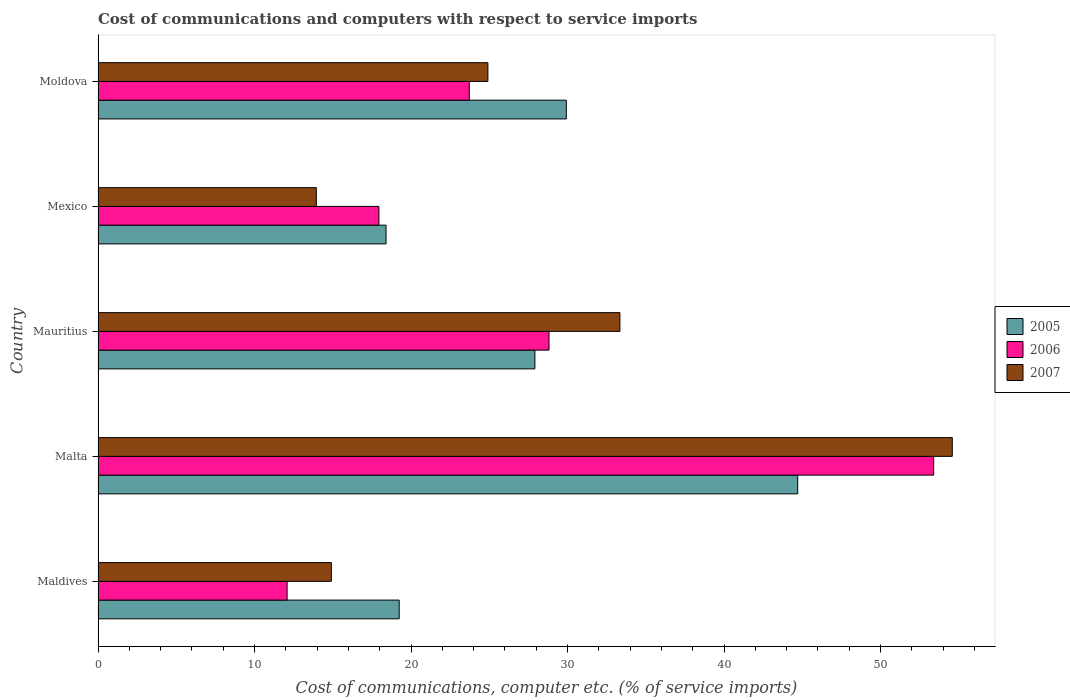How many different coloured bars are there?
Offer a very short reply. 3. Are the number of bars on each tick of the Y-axis equal?
Keep it short and to the point. Yes. What is the label of the 2nd group of bars from the top?
Keep it short and to the point. Mexico. What is the cost of communications and computers in 2007 in Mauritius?
Provide a succinct answer. 33.35. Across all countries, what is the maximum cost of communications and computers in 2005?
Your response must be concise. 44.71. Across all countries, what is the minimum cost of communications and computers in 2005?
Keep it short and to the point. 18.4. In which country was the cost of communications and computers in 2007 maximum?
Make the answer very short. Malta. What is the total cost of communications and computers in 2005 in the graph?
Your response must be concise. 140.18. What is the difference between the cost of communications and computers in 2005 in Maldives and that in Mauritius?
Offer a terse response. -8.67. What is the difference between the cost of communications and computers in 2006 in Maldives and the cost of communications and computers in 2005 in Mexico?
Give a very brief answer. -6.32. What is the average cost of communications and computers in 2005 per country?
Offer a terse response. 28.04. What is the difference between the cost of communications and computers in 2006 and cost of communications and computers in 2005 in Malta?
Your answer should be very brief. 8.69. In how many countries, is the cost of communications and computers in 2007 greater than 14 %?
Keep it short and to the point. 4. What is the ratio of the cost of communications and computers in 2005 in Maldives to that in Malta?
Offer a terse response. 0.43. Is the cost of communications and computers in 2006 in Mauritius less than that in Moldova?
Keep it short and to the point. No. What is the difference between the highest and the second highest cost of communications and computers in 2006?
Offer a terse response. 24.58. What is the difference between the highest and the lowest cost of communications and computers in 2005?
Make the answer very short. 26.3. In how many countries, is the cost of communications and computers in 2005 greater than the average cost of communications and computers in 2005 taken over all countries?
Provide a short and direct response. 2. What does the 2nd bar from the bottom in Mexico represents?
Provide a succinct answer. 2006. Is it the case that in every country, the sum of the cost of communications and computers in 2006 and cost of communications and computers in 2005 is greater than the cost of communications and computers in 2007?
Ensure brevity in your answer.  Yes. How many bars are there?
Keep it short and to the point. 15. What is the difference between two consecutive major ticks on the X-axis?
Keep it short and to the point. 10. Are the values on the major ticks of X-axis written in scientific E-notation?
Ensure brevity in your answer.  No. Does the graph contain any zero values?
Ensure brevity in your answer.  No. Where does the legend appear in the graph?
Offer a very short reply. Center right. How many legend labels are there?
Offer a very short reply. 3. How are the legend labels stacked?
Keep it short and to the point. Vertical. What is the title of the graph?
Make the answer very short. Cost of communications and computers with respect to service imports. What is the label or title of the X-axis?
Ensure brevity in your answer.  Cost of communications, computer etc. (% of service imports). What is the Cost of communications, computer etc. (% of service imports) in 2005 in Maldives?
Provide a succinct answer. 19.24. What is the Cost of communications, computer etc. (% of service imports) of 2006 in Maldives?
Offer a terse response. 12.08. What is the Cost of communications, computer etc. (% of service imports) in 2007 in Maldives?
Keep it short and to the point. 14.91. What is the Cost of communications, computer etc. (% of service imports) of 2005 in Malta?
Your answer should be compact. 44.71. What is the Cost of communications, computer etc. (% of service imports) in 2006 in Malta?
Provide a short and direct response. 53.4. What is the Cost of communications, computer etc. (% of service imports) of 2007 in Malta?
Offer a very short reply. 54.58. What is the Cost of communications, computer etc. (% of service imports) of 2005 in Mauritius?
Offer a terse response. 27.91. What is the Cost of communications, computer etc. (% of service imports) in 2006 in Mauritius?
Give a very brief answer. 28.82. What is the Cost of communications, computer etc. (% of service imports) in 2007 in Mauritius?
Ensure brevity in your answer.  33.35. What is the Cost of communications, computer etc. (% of service imports) of 2005 in Mexico?
Offer a terse response. 18.4. What is the Cost of communications, computer etc. (% of service imports) in 2006 in Mexico?
Keep it short and to the point. 17.95. What is the Cost of communications, computer etc. (% of service imports) of 2007 in Mexico?
Keep it short and to the point. 13.95. What is the Cost of communications, computer etc. (% of service imports) of 2005 in Moldova?
Keep it short and to the point. 29.92. What is the Cost of communications, computer etc. (% of service imports) of 2006 in Moldova?
Offer a terse response. 23.72. What is the Cost of communications, computer etc. (% of service imports) in 2007 in Moldova?
Offer a terse response. 24.91. Across all countries, what is the maximum Cost of communications, computer etc. (% of service imports) in 2005?
Your answer should be very brief. 44.71. Across all countries, what is the maximum Cost of communications, computer etc. (% of service imports) of 2006?
Make the answer very short. 53.4. Across all countries, what is the maximum Cost of communications, computer etc. (% of service imports) in 2007?
Keep it short and to the point. 54.58. Across all countries, what is the minimum Cost of communications, computer etc. (% of service imports) in 2005?
Provide a short and direct response. 18.4. Across all countries, what is the minimum Cost of communications, computer etc. (% of service imports) of 2006?
Your answer should be very brief. 12.08. Across all countries, what is the minimum Cost of communications, computer etc. (% of service imports) of 2007?
Make the answer very short. 13.95. What is the total Cost of communications, computer etc. (% of service imports) in 2005 in the graph?
Provide a succinct answer. 140.18. What is the total Cost of communications, computer etc. (% of service imports) in 2006 in the graph?
Your response must be concise. 135.96. What is the total Cost of communications, computer etc. (% of service imports) of 2007 in the graph?
Offer a terse response. 141.69. What is the difference between the Cost of communications, computer etc. (% of service imports) in 2005 in Maldives and that in Malta?
Ensure brevity in your answer.  -25.46. What is the difference between the Cost of communications, computer etc. (% of service imports) of 2006 in Maldives and that in Malta?
Keep it short and to the point. -41.31. What is the difference between the Cost of communications, computer etc. (% of service imports) of 2007 in Maldives and that in Malta?
Keep it short and to the point. -39.68. What is the difference between the Cost of communications, computer etc. (% of service imports) in 2005 in Maldives and that in Mauritius?
Keep it short and to the point. -8.67. What is the difference between the Cost of communications, computer etc. (% of service imports) in 2006 in Maldives and that in Mauritius?
Offer a terse response. -16.73. What is the difference between the Cost of communications, computer etc. (% of service imports) in 2007 in Maldives and that in Mauritius?
Your answer should be very brief. -18.44. What is the difference between the Cost of communications, computer etc. (% of service imports) of 2005 in Maldives and that in Mexico?
Make the answer very short. 0.84. What is the difference between the Cost of communications, computer etc. (% of service imports) of 2006 in Maldives and that in Mexico?
Keep it short and to the point. -5.87. What is the difference between the Cost of communications, computer etc. (% of service imports) of 2007 in Maldives and that in Mexico?
Offer a very short reply. 0.96. What is the difference between the Cost of communications, computer etc. (% of service imports) of 2005 in Maldives and that in Moldova?
Make the answer very short. -10.68. What is the difference between the Cost of communications, computer etc. (% of service imports) of 2006 in Maldives and that in Moldova?
Make the answer very short. -11.64. What is the difference between the Cost of communications, computer etc. (% of service imports) of 2007 in Maldives and that in Moldova?
Your answer should be very brief. -10. What is the difference between the Cost of communications, computer etc. (% of service imports) in 2005 in Malta and that in Mauritius?
Offer a terse response. 16.79. What is the difference between the Cost of communications, computer etc. (% of service imports) in 2006 in Malta and that in Mauritius?
Keep it short and to the point. 24.58. What is the difference between the Cost of communications, computer etc. (% of service imports) of 2007 in Malta and that in Mauritius?
Provide a short and direct response. 21.24. What is the difference between the Cost of communications, computer etc. (% of service imports) in 2005 in Malta and that in Mexico?
Make the answer very short. 26.3. What is the difference between the Cost of communications, computer etc. (% of service imports) of 2006 in Malta and that in Mexico?
Provide a succinct answer. 35.45. What is the difference between the Cost of communications, computer etc. (% of service imports) of 2007 in Malta and that in Mexico?
Your answer should be compact. 40.64. What is the difference between the Cost of communications, computer etc. (% of service imports) of 2005 in Malta and that in Moldova?
Keep it short and to the point. 14.79. What is the difference between the Cost of communications, computer etc. (% of service imports) of 2006 in Malta and that in Moldova?
Your answer should be compact. 29.67. What is the difference between the Cost of communications, computer etc. (% of service imports) in 2007 in Malta and that in Moldova?
Your response must be concise. 29.67. What is the difference between the Cost of communications, computer etc. (% of service imports) in 2005 in Mauritius and that in Mexico?
Your answer should be compact. 9.51. What is the difference between the Cost of communications, computer etc. (% of service imports) in 2006 in Mauritius and that in Mexico?
Offer a terse response. 10.87. What is the difference between the Cost of communications, computer etc. (% of service imports) in 2007 in Mauritius and that in Mexico?
Your answer should be very brief. 19.4. What is the difference between the Cost of communications, computer etc. (% of service imports) of 2005 in Mauritius and that in Moldova?
Your response must be concise. -2.01. What is the difference between the Cost of communications, computer etc. (% of service imports) in 2006 in Mauritius and that in Moldova?
Your response must be concise. 5.09. What is the difference between the Cost of communications, computer etc. (% of service imports) of 2007 in Mauritius and that in Moldova?
Make the answer very short. 8.44. What is the difference between the Cost of communications, computer etc. (% of service imports) of 2005 in Mexico and that in Moldova?
Ensure brevity in your answer.  -11.52. What is the difference between the Cost of communications, computer etc. (% of service imports) of 2006 in Mexico and that in Moldova?
Your answer should be very brief. -5.77. What is the difference between the Cost of communications, computer etc. (% of service imports) of 2007 in Mexico and that in Moldova?
Give a very brief answer. -10.96. What is the difference between the Cost of communications, computer etc. (% of service imports) in 2005 in Maldives and the Cost of communications, computer etc. (% of service imports) in 2006 in Malta?
Your answer should be compact. -34.15. What is the difference between the Cost of communications, computer etc. (% of service imports) in 2005 in Maldives and the Cost of communications, computer etc. (% of service imports) in 2007 in Malta?
Ensure brevity in your answer.  -35.34. What is the difference between the Cost of communications, computer etc. (% of service imports) in 2006 in Maldives and the Cost of communications, computer etc. (% of service imports) in 2007 in Malta?
Provide a succinct answer. -42.5. What is the difference between the Cost of communications, computer etc. (% of service imports) in 2005 in Maldives and the Cost of communications, computer etc. (% of service imports) in 2006 in Mauritius?
Give a very brief answer. -9.57. What is the difference between the Cost of communications, computer etc. (% of service imports) in 2005 in Maldives and the Cost of communications, computer etc. (% of service imports) in 2007 in Mauritius?
Offer a terse response. -14.1. What is the difference between the Cost of communications, computer etc. (% of service imports) in 2006 in Maldives and the Cost of communications, computer etc. (% of service imports) in 2007 in Mauritius?
Provide a succinct answer. -21.27. What is the difference between the Cost of communications, computer etc. (% of service imports) of 2005 in Maldives and the Cost of communications, computer etc. (% of service imports) of 2006 in Mexico?
Your response must be concise. 1.3. What is the difference between the Cost of communications, computer etc. (% of service imports) in 2005 in Maldives and the Cost of communications, computer etc. (% of service imports) in 2007 in Mexico?
Provide a succinct answer. 5.3. What is the difference between the Cost of communications, computer etc. (% of service imports) of 2006 in Maldives and the Cost of communications, computer etc. (% of service imports) of 2007 in Mexico?
Offer a terse response. -1.87. What is the difference between the Cost of communications, computer etc. (% of service imports) of 2005 in Maldives and the Cost of communications, computer etc. (% of service imports) of 2006 in Moldova?
Offer a terse response. -4.48. What is the difference between the Cost of communications, computer etc. (% of service imports) of 2005 in Maldives and the Cost of communications, computer etc. (% of service imports) of 2007 in Moldova?
Offer a very short reply. -5.67. What is the difference between the Cost of communications, computer etc. (% of service imports) in 2006 in Maldives and the Cost of communications, computer etc. (% of service imports) in 2007 in Moldova?
Your answer should be very brief. -12.83. What is the difference between the Cost of communications, computer etc. (% of service imports) in 2005 in Malta and the Cost of communications, computer etc. (% of service imports) in 2006 in Mauritius?
Ensure brevity in your answer.  15.89. What is the difference between the Cost of communications, computer etc. (% of service imports) in 2005 in Malta and the Cost of communications, computer etc. (% of service imports) in 2007 in Mauritius?
Ensure brevity in your answer.  11.36. What is the difference between the Cost of communications, computer etc. (% of service imports) of 2006 in Malta and the Cost of communications, computer etc. (% of service imports) of 2007 in Mauritius?
Your answer should be compact. 20.05. What is the difference between the Cost of communications, computer etc. (% of service imports) in 2005 in Malta and the Cost of communications, computer etc. (% of service imports) in 2006 in Mexico?
Offer a terse response. 26.76. What is the difference between the Cost of communications, computer etc. (% of service imports) of 2005 in Malta and the Cost of communications, computer etc. (% of service imports) of 2007 in Mexico?
Keep it short and to the point. 30.76. What is the difference between the Cost of communications, computer etc. (% of service imports) of 2006 in Malta and the Cost of communications, computer etc. (% of service imports) of 2007 in Mexico?
Make the answer very short. 39.45. What is the difference between the Cost of communications, computer etc. (% of service imports) of 2005 in Malta and the Cost of communications, computer etc. (% of service imports) of 2006 in Moldova?
Offer a terse response. 20.99. What is the difference between the Cost of communications, computer etc. (% of service imports) in 2005 in Malta and the Cost of communications, computer etc. (% of service imports) in 2007 in Moldova?
Offer a very short reply. 19.8. What is the difference between the Cost of communications, computer etc. (% of service imports) in 2006 in Malta and the Cost of communications, computer etc. (% of service imports) in 2007 in Moldova?
Make the answer very short. 28.49. What is the difference between the Cost of communications, computer etc. (% of service imports) of 2005 in Mauritius and the Cost of communications, computer etc. (% of service imports) of 2006 in Mexico?
Your answer should be compact. 9.97. What is the difference between the Cost of communications, computer etc. (% of service imports) in 2005 in Mauritius and the Cost of communications, computer etc. (% of service imports) in 2007 in Mexico?
Provide a short and direct response. 13.97. What is the difference between the Cost of communications, computer etc. (% of service imports) in 2006 in Mauritius and the Cost of communications, computer etc. (% of service imports) in 2007 in Mexico?
Ensure brevity in your answer.  14.87. What is the difference between the Cost of communications, computer etc. (% of service imports) in 2005 in Mauritius and the Cost of communications, computer etc. (% of service imports) in 2006 in Moldova?
Offer a terse response. 4.19. What is the difference between the Cost of communications, computer etc. (% of service imports) of 2005 in Mauritius and the Cost of communications, computer etc. (% of service imports) of 2007 in Moldova?
Offer a terse response. 3. What is the difference between the Cost of communications, computer etc. (% of service imports) in 2006 in Mauritius and the Cost of communications, computer etc. (% of service imports) in 2007 in Moldova?
Provide a succinct answer. 3.91. What is the difference between the Cost of communications, computer etc. (% of service imports) of 2005 in Mexico and the Cost of communications, computer etc. (% of service imports) of 2006 in Moldova?
Ensure brevity in your answer.  -5.32. What is the difference between the Cost of communications, computer etc. (% of service imports) of 2005 in Mexico and the Cost of communications, computer etc. (% of service imports) of 2007 in Moldova?
Keep it short and to the point. -6.51. What is the difference between the Cost of communications, computer etc. (% of service imports) of 2006 in Mexico and the Cost of communications, computer etc. (% of service imports) of 2007 in Moldova?
Your response must be concise. -6.96. What is the average Cost of communications, computer etc. (% of service imports) of 2005 per country?
Keep it short and to the point. 28.04. What is the average Cost of communications, computer etc. (% of service imports) of 2006 per country?
Your answer should be very brief. 27.19. What is the average Cost of communications, computer etc. (% of service imports) in 2007 per country?
Your answer should be very brief. 28.34. What is the difference between the Cost of communications, computer etc. (% of service imports) in 2005 and Cost of communications, computer etc. (% of service imports) in 2006 in Maldives?
Your response must be concise. 7.16. What is the difference between the Cost of communications, computer etc. (% of service imports) in 2005 and Cost of communications, computer etc. (% of service imports) in 2007 in Maldives?
Ensure brevity in your answer.  4.33. What is the difference between the Cost of communications, computer etc. (% of service imports) in 2006 and Cost of communications, computer etc. (% of service imports) in 2007 in Maldives?
Give a very brief answer. -2.83. What is the difference between the Cost of communications, computer etc. (% of service imports) of 2005 and Cost of communications, computer etc. (% of service imports) of 2006 in Malta?
Provide a short and direct response. -8.69. What is the difference between the Cost of communications, computer etc. (% of service imports) of 2005 and Cost of communications, computer etc. (% of service imports) of 2007 in Malta?
Your answer should be very brief. -9.88. What is the difference between the Cost of communications, computer etc. (% of service imports) of 2006 and Cost of communications, computer etc. (% of service imports) of 2007 in Malta?
Provide a short and direct response. -1.19. What is the difference between the Cost of communications, computer etc. (% of service imports) of 2005 and Cost of communications, computer etc. (% of service imports) of 2006 in Mauritius?
Your answer should be very brief. -0.9. What is the difference between the Cost of communications, computer etc. (% of service imports) of 2005 and Cost of communications, computer etc. (% of service imports) of 2007 in Mauritius?
Your response must be concise. -5.43. What is the difference between the Cost of communications, computer etc. (% of service imports) in 2006 and Cost of communications, computer etc. (% of service imports) in 2007 in Mauritius?
Your answer should be very brief. -4.53. What is the difference between the Cost of communications, computer etc. (% of service imports) of 2005 and Cost of communications, computer etc. (% of service imports) of 2006 in Mexico?
Your response must be concise. 0.46. What is the difference between the Cost of communications, computer etc. (% of service imports) in 2005 and Cost of communications, computer etc. (% of service imports) in 2007 in Mexico?
Ensure brevity in your answer.  4.46. What is the difference between the Cost of communications, computer etc. (% of service imports) of 2006 and Cost of communications, computer etc. (% of service imports) of 2007 in Mexico?
Provide a short and direct response. 4. What is the difference between the Cost of communications, computer etc. (% of service imports) in 2005 and Cost of communications, computer etc. (% of service imports) in 2007 in Moldova?
Offer a terse response. 5.01. What is the difference between the Cost of communications, computer etc. (% of service imports) in 2006 and Cost of communications, computer etc. (% of service imports) in 2007 in Moldova?
Offer a terse response. -1.19. What is the ratio of the Cost of communications, computer etc. (% of service imports) of 2005 in Maldives to that in Malta?
Offer a very short reply. 0.43. What is the ratio of the Cost of communications, computer etc. (% of service imports) of 2006 in Maldives to that in Malta?
Offer a terse response. 0.23. What is the ratio of the Cost of communications, computer etc. (% of service imports) of 2007 in Maldives to that in Malta?
Ensure brevity in your answer.  0.27. What is the ratio of the Cost of communications, computer etc. (% of service imports) in 2005 in Maldives to that in Mauritius?
Your response must be concise. 0.69. What is the ratio of the Cost of communications, computer etc. (% of service imports) in 2006 in Maldives to that in Mauritius?
Ensure brevity in your answer.  0.42. What is the ratio of the Cost of communications, computer etc. (% of service imports) in 2007 in Maldives to that in Mauritius?
Offer a very short reply. 0.45. What is the ratio of the Cost of communications, computer etc. (% of service imports) in 2005 in Maldives to that in Mexico?
Your answer should be compact. 1.05. What is the ratio of the Cost of communications, computer etc. (% of service imports) of 2006 in Maldives to that in Mexico?
Offer a terse response. 0.67. What is the ratio of the Cost of communications, computer etc. (% of service imports) in 2007 in Maldives to that in Mexico?
Your answer should be very brief. 1.07. What is the ratio of the Cost of communications, computer etc. (% of service imports) in 2005 in Maldives to that in Moldova?
Ensure brevity in your answer.  0.64. What is the ratio of the Cost of communications, computer etc. (% of service imports) of 2006 in Maldives to that in Moldova?
Make the answer very short. 0.51. What is the ratio of the Cost of communications, computer etc. (% of service imports) of 2007 in Maldives to that in Moldova?
Give a very brief answer. 0.6. What is the ratio of the Cost of communications, computer etc. (% of service imports) of 2005 in Malta to that in Mauritius?
Ensure brevity in your answer.  1.6. What is the ratio of the Cost of communications, computer etc. (% of service imports) in 2006 in Malta to that in Mauritius?
Give a very brief answer. 1.85. What is the ratio of the Cost of communications, computer etc. (% of service imports) in 2007 in Malta to that in Mauritius?
Your response must be concise. 1.64. What is the ratio of the Cost of communications, computer etc. (% of service imports) of 2005 in Malta to that in Mexico?
Give a very brief answer. 2.43. What is the ratio of the Cost of communications, computer etc. (% of service imports) of 2006 in Malta to that in Mexico?
Ensure brevity in your answer.  2.98. What is the ratio of the Cost of communications, computer etc. (% of service imports) of 2007 in Malta to that in Mexico?
Make the answer very short. 3.91. What is the ratio of the Cost of communications, computer etc. (% of service imports) in 2005 in Malta to that in Moldova?
Provide a short and direct response. 1.49. What is the ratio of the Cost of communications, computer etc. (% of service imports) of 2006 in Malta to that in Moldova?
Your answer should be very brief. 2.25. What is the ratio of the Cost of communications, computer etc. (% of service imports) in 2007 in Malta to that in Moldova?
Your answer should be very brief. 2.19. What is the ratio of the Cost of communications, computer etc. (% of service imports) in 2005 in Mauritius to that in Mexico?
Your answer should be compact. 1.52. What is the ratio of the Cost of communications, computer etc. (% of service imports) of 2006 in Mauritius to that in Mexico?
Your response must be concise. 1.61. What is the ratio of the Cost of communications, computer etc. (% of service imports) of 2007 in Mauritius to that in Mexico?
Give a very brief answer. 2.39. What is the ratio of the Cost of communications, computer etc. (% of service imports) of 2005 in Mauritius to that in Moldova?
Offer a terse response. 0.93. What is the ratio of the Cost of communications, computer etc. (% of service imports) in 2006 in Mauritius to that in Moldova?
Provide a succinct answer. 1.21. What is the ratio of the Cost of communications, computer etc. (% of service imports) in 2007 in Mauritius to that in Moldova?
Provide a short and direct response. 1.34. What is the ratio of the Cost of communications, computer etc. (% of service imports) of 2005 in Mexico to that in Moldova?
Keep it short and to the point. 0.61. What is the ratio of the Cost of communications, computer etc. (% of service imports) of 2006 in Mexico to that in Moldova?
Offer a very short reply. 0.76. What is the ratio of the Cost of communications, computer etc. (% of service imports) in 2007 in Mexico to that in Moldova?
Keep it short and to the point. 0.56. What is the difference between the highest and the second highest Cost of communications, computer etc. (% of service imports) in 2005?
Offer a very short reply. 14.79. What is the difference between the highest and the second highest Cost of communications, computer etc. (% of service imports) of 2006?
Ensure brevity in your answer.  24.58. What is the difference between the highest and the second highest Cost of communications, computer etc. (% of service imports) of 2007?
Offer a terse response. 21.24. What is the difference between the highest and the lowest Cost of communications, computer etc. (% of service imports) of 2005?
Ensure brevity in your answer.  26.3. What is the difference between the highest and the lowest Cost of communications, computer etc. (% of service imports) of 2006?
Provide a succinct answer. 41.31. What is the difference between the highest and the lowest Cost of communications, computer etc. (% of service imports) of 2007?
Your answer should be very brief. 40.64. 